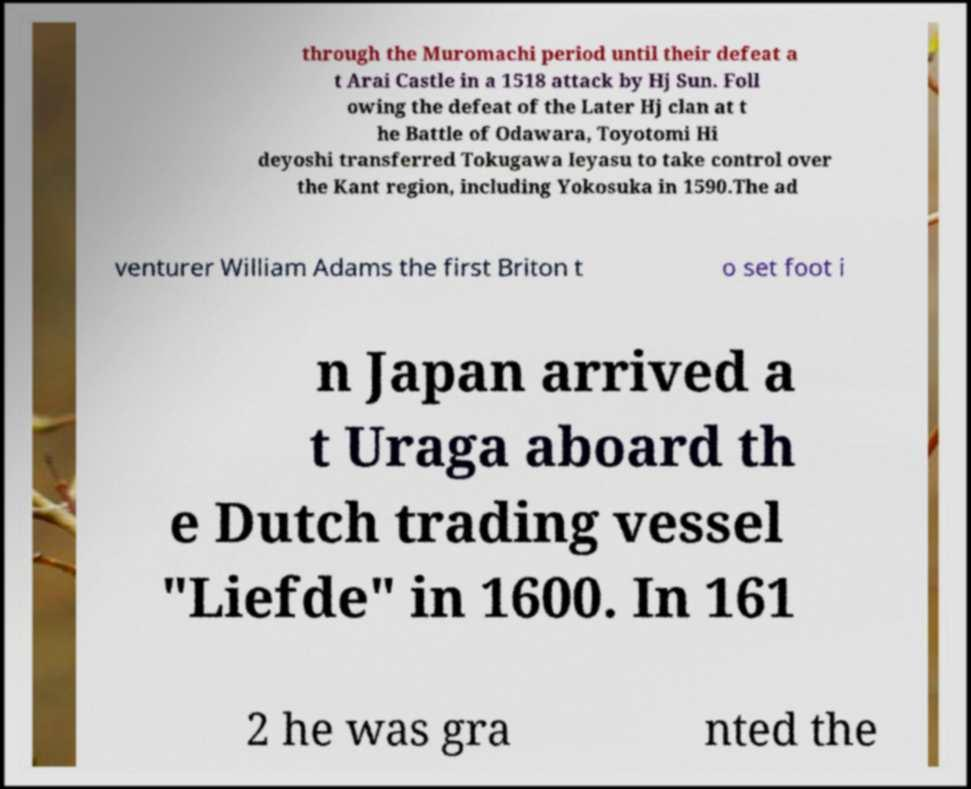Can you read and provide the text displayed in the image?This photo seems to have some interesting text. Can you extract and type it out for me? through the Muromachi period until their defeat a t Arai Castle in a 1518 attack by Hj Sun. Foll owing the defeat of the Later Hj clan at t he Battle of Odawara, Toyotomi Hi deyoshi transferred Tokugawa Ieyasu to take control over the Kant region, including Yokosuka in 1590.The ad venturer William Adams the first Briton t o set foot i n Japan arrived a t Uraga aboard th e Dutch trading vessel "Liefde" in 1600. In 161 2 he was gra nted the 